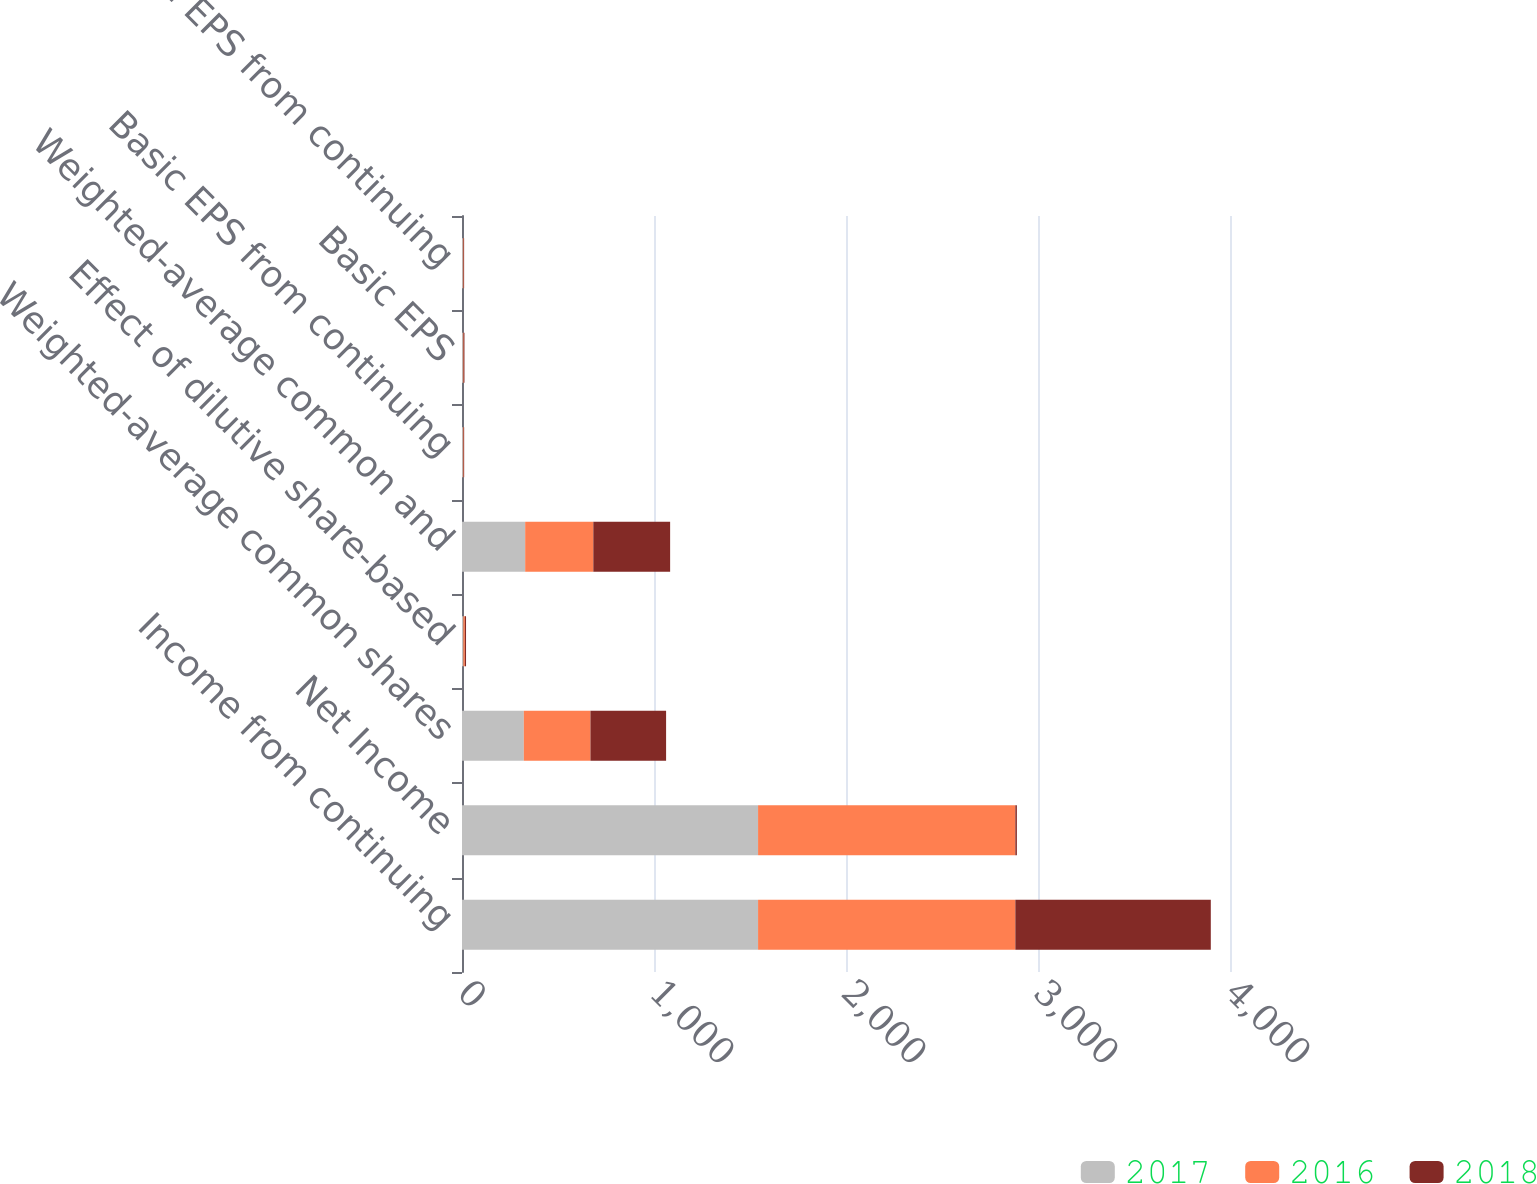<chart> <loc_0><loc_0><loc_500><loc_500><stacked_bar_chart><ecel><fcel>Income from continuing<fcel>Net Income<fcel>Weighted-average common shares<fcel>Effect of dilutive share-based<fcel>Weighted-average common and<fcel>Basic EPS from continuing<fcel>Basic EPS<fcel>Diluted EPS from continuing<nl><fcel>2017<fcel>1542<fcel>1542<fcel>322<fcel>7<fcel>329<fcel>4.8<fcel>4.8<fcel>4.69<nl><fcel>2016<fcel>1340<fcel>1340<fcel>347<fcel>8<fcel>355<fcel>3.86<fcel>3.86<fcel>3.77<nl><fcel>2018<fcel>1018<fcel>8<fcel>394<fcel>6<fcel>400<fcel>2.58<fcel>4.17<fcel>2.54<nl></chart> 